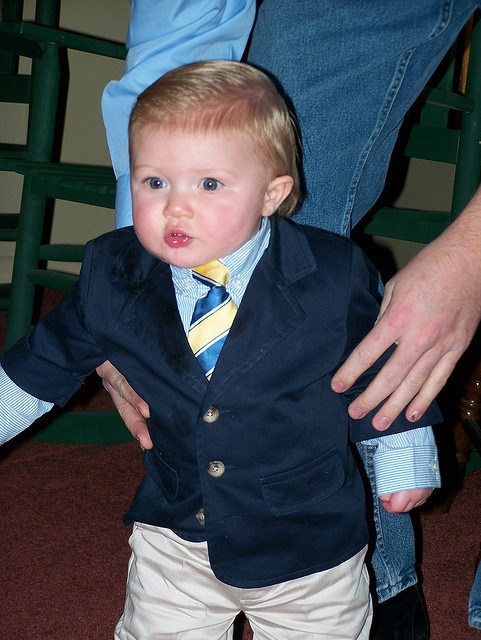Describe the objects in this image and their specific colors. I can see people in black, navy, lightgray, and lightpink tones, people in black, blue, lightpink, and lightblue tones, and tie in black, beige, khaki, blue, and lightblue tones in this image. 